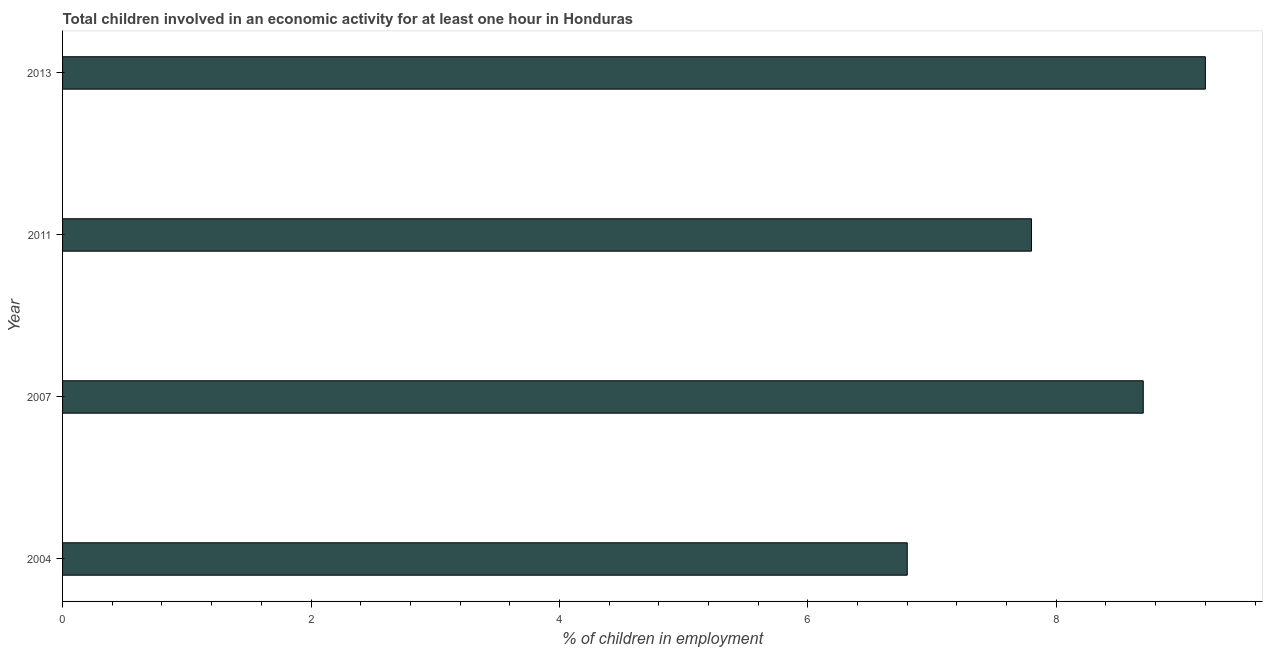Does the graph contain grids?
Offer a terse response. No. What is the title of the graph?
Your response must be concise. Total children involved in an economic activity for at least one hour in Honduras. What is the label or title of the X-axis?
Make the answer very short. % of children in employment. What is the label or title of the Y-axis?
Make the answer very short. Year. What is the percentage of children in employment in 2004?
Your answer should be very brief. 6.8. Across all years, what is the maximum percentage of children in employment?
Ensure brevity in your answer.  9.2. Across all years, what is the minimum percentage of children in employment?
Your response must be concise. 6.8. In which year was the percentage of children in employment minimum?
Your answer should be compact. 2004. What is the sum of the percentage of children in employment?
Give a very brief answer. 32.5. What is the average percentage of children in employment per year?
Your answer should be very brief. 8.12. What is the median percentage of children in employment?
Provide a short and direct response. 8.25. In how many years, is the percentage of children in employment greater than 0.8 %?
Provide a short and direct response. 4. What is the ratio of the percentage of children in employment in 2004 to that in 2013?
Your response must be concise. 0.74. Is the sum of the percentage of children in employment in 2004 and 2011 greater than the maximum percentage of children in employment across all years?
Give a very brief answer. Yes. How many bars are there?
Give a very brief answer. 4. How many years are there in the graph?
Offer a terse response. 4. What is the % of children in employment in 2004?
Your answer should be compact. 6.8. What is the % of children in employment in 2007?
Offer a very short reply. 8.7. What is the % of children in employment in 2011?
Keep it short and to the point. 7.8. What is the difference between the % of children in employment in 2004 and 2011?
Your response must be concise. -1. What is the difference between the % of children in employment in 2004 and 2013?
Keep it short and to the point. -2.4. What is the difference between the % of children in employment in 2007 and 2013?
Your answer should be compact. -0.5. What is the difference between the % of children in employment in 2011 and 2013?
Offer a very short reply. -1.4. What is the ratio of the % of children in employment in 2004 to that in 2007?
Provide a short and direct response. 0.78. What is the ratio of the % of children in employment in 2004 to that in 2011?
Offer a very short reply. 0.87. What is the ratio of the % of children in employment in 2004 to that in 2013?
Keep it short and to the point. 0.74. What is the ratio of the % of children in employment in 2007 to that in 2011?
Your answer should be very brief. 1.11. What is the ratio of the % of children in employment in 2007 to that in 2013?
Ensure brevity in your answer.  0.95. What is the ratio of the % of children in employment in 2011 to that in 2013?
Provide a succinct answer. 0.85. 